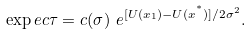Convert formula to latex. <formula><loc_0><loc_0><loc_500><loc_500>\exp e c { \tau } = c ( \sigma ) \ e ^ { [ U ( x _ { 1 } ) - U ( x ^ { ^ { * } } ) ] / 2 \sigma ^ { 2 } } .</formula> 